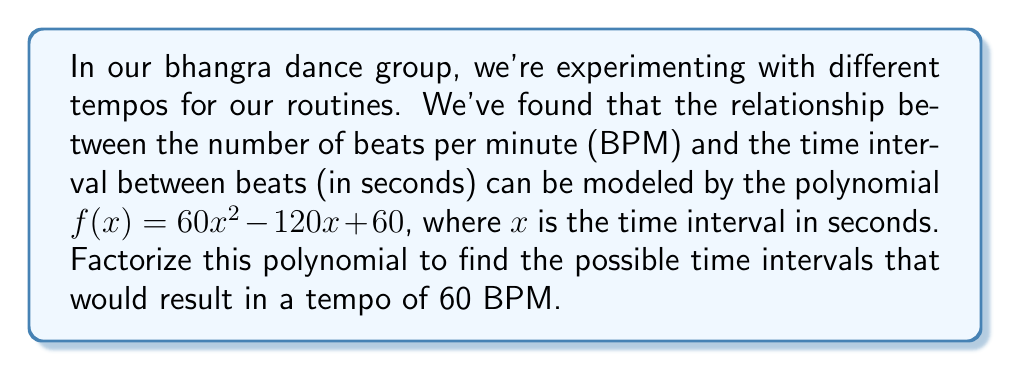Show me your answer to this math problem. Let's approach this step-by-step:

1) The polynomial we need to factorize is $f(x) = 60x^2 - 120x + 60$.

2) First, let's factor out the greatest common factor (GCF):
   $f(x) = 60(x^2 - 2x + 1)$

3) The expression inside the parentheses is a quadratic trinomial. To factorize it, we can use the method of finding two numbers that multiply to give the constant term (1) and add up to the coefficient of x (-2).

4) These numbers are -1 and -1.

5) We can rewrite the quadratic as:
   $60(x^2 - x - x + 1)$

6) Grouping the terms:
   $60(x(x - 1) - 1(x - 1))$

7) Factoring out $(x - 1)$:
   $60((x - 1)(x - 1))$

8) This can be written as:
   $f(x) = 60(x - 1)^2$

9) For a tempo of 60 BPM, $f(x) = 0$. So we solve:
   $60(x - 1)^2 = 0$

10) Dividing both sides by 60:
    $(x - 1)^2 = 0$

11) Taking the square root of both sides:
    $x - 1 = 0$

12) Solving for $x$:
    $x = 1$

Therefore, the time interval that results in a tempo of 60 BPM is 1 second.
Answer: $f(x) = 60(x - 1)^2$; $x = 1$ second 